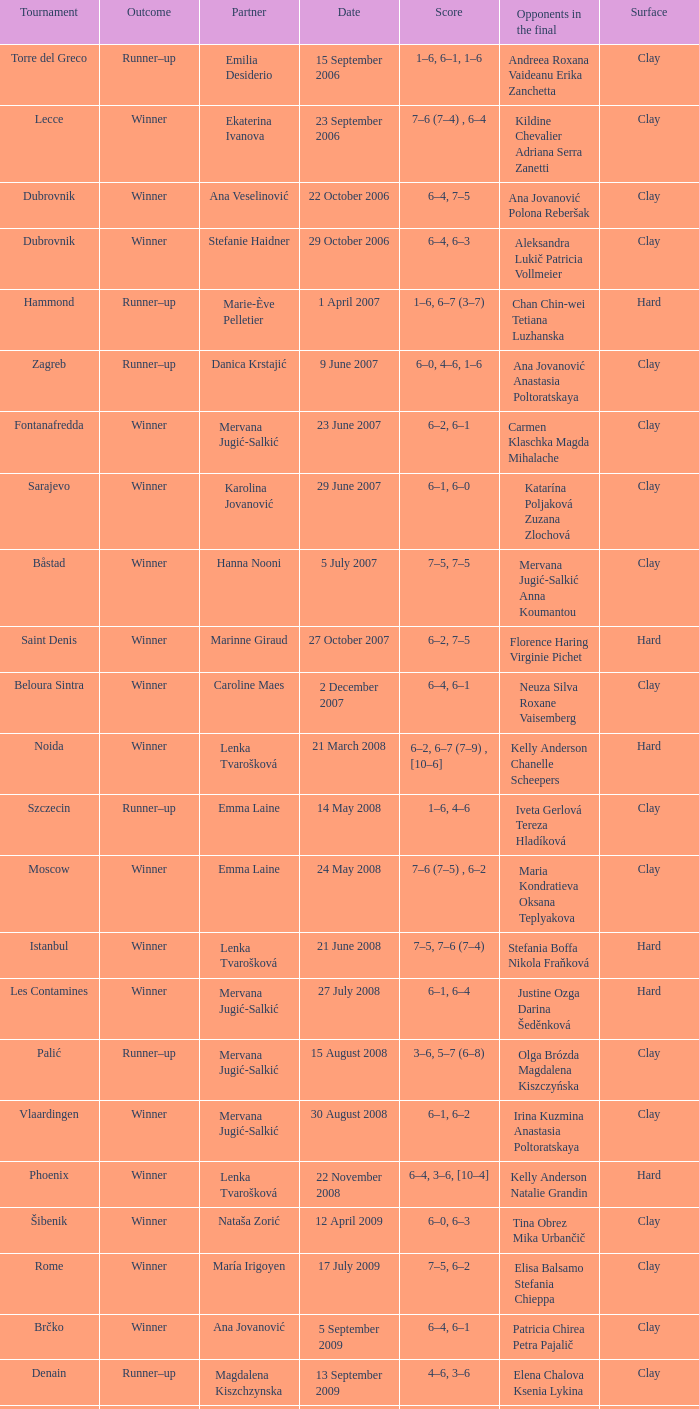Which tournament had a partner of Erika Sema? Aschaffenburg. 